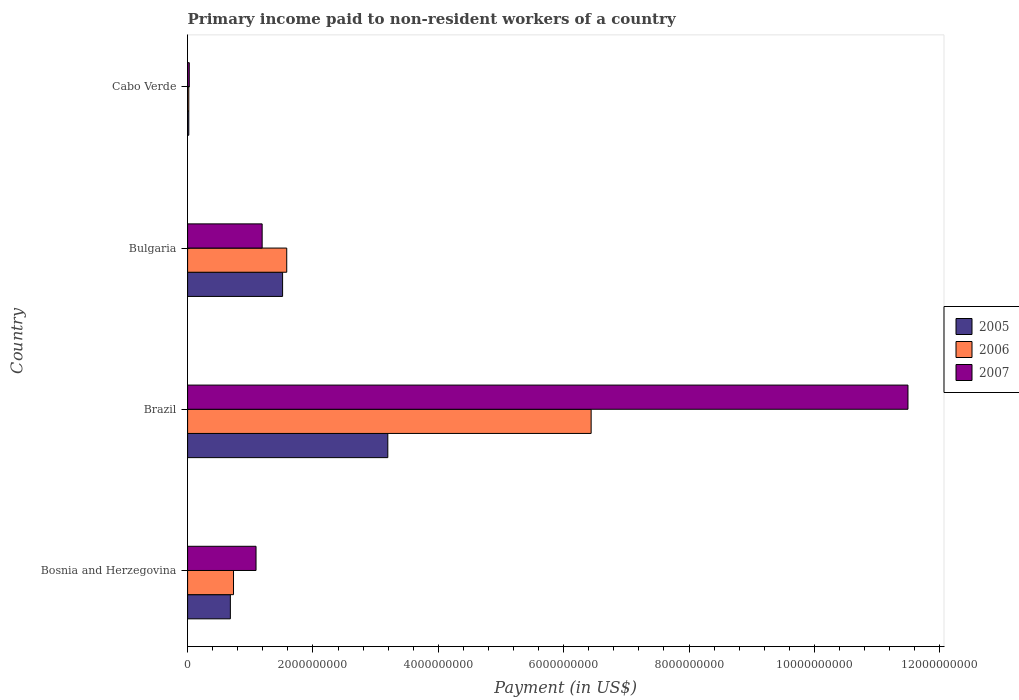How many different coloured bars are there?
Ensure brevity in your answer.  3. How many groups of bars are there?
Make the answer very short. 4. Are the number of bars per tick equal to the number of legend labels?
Give a very brief answer. Yes. Are the number of bars on each tick of the Y-axis equal?
Ensure brevity in your answer.  Yes. How many bars are there on the 1st tick from the top?
Your answer should be compact. 3. How many bars are there on the 4th tick from the bottom?
Provide a succinct answer. 3. What is the label of the 4th group of bars from the top?
Your answer should be very brief. Bosnia and Herzegovina. What is the amount paid to workers in 2006 in Bosnia and Herzegovina?
Ensure brevity in your answer.  7.33e+08. Across all countries, what is the maximum amount paid to workers in 2007?
Keep it short and to the point. 1.15e+1. Across all countries, what is the minimum amount paid to workers in 2006?
Keep it short and to the point. 1.91e+07. In which country was the amount paid to workers in 2006 minimum?
Keep it short and to the point. Cabo Verde. What is the total amount paid to workers in 2005 in the graph?
Keep it short and to the point. 5.41e+09. What is the difference between the amount paid to workers in 2007 in Bulgaria and that in Cabo Verde?
Provide a short and direct response. 1.16e+09. What is the difference between the amount paid to workers in 2007 in Cabo Verde and the amount paid to workers in 2006 in Brazil?
Offer a terse response. -6.41e+09. What is the average amount paid to workers in 2007 per country?
Provide a short and direct response. 3.45e+09. What is the difference between the amount paid to workers in 2005 and amount paid to workers in 2006 in Bosnia and Herzegovina?
Offer a terse response. -5.03e+07. In how many countries, is the amount paid to workers in 2006 greater than 2800000000 US$?
Your answer should be compact. 1. What is the ratio of the amount paid to workers in 2006 in Bosnia and Herzegovina to that in Cabo Verde?
Provide a short and direct response. 38.41. Is the difference between the amount paid to workers in 2005 in Brazil and Bulgaria greater than the difference between the amount paid to workers in 2006 in Brazil and Bulgaria?
Offer a very short reply. No. What is the difference between the highest and the second highest amount paid to workers in 2005?
Ensure brevity in your answer.  1.68e+09. What is the difference between the highest and the lowest amount paid to workers in 2007?
Offer a terse response. 1.15e+1. In how many countries, is the amount paid to workers in 2007 greater than the average amount paid to workers in 2007 taken over all countries?
Ensure brevity in your answer.  1. What does the 3rd bar from the bottom in Cabo Verde represents?
Give a very brief answer. 2007. Are the values on the major ticks of X-axis written in scientific E-notation?
Provide a succinct answer. No. How are the legend labels stacked?
Offer a very short reply. Vertical. What is the title of the graph?
Give a very brief answer. Primary income paid to non-resident workers of a country. What is the label or title of the X-axis?
Your answer should be very brief. Payment (in US$). What is the label or title of the Y-axis?
Offer a very short reply. Country. What is the Payment (in US$) of 2005 in Bosnia and Herzegovina?
Provide a succinct answer. 6.82e+08. What is the Payment (in US$) in 2006 in Bosnia and Herzegovina?
Give a very brief answer. 7.33e+08. What is the Payment (in US$) in 2007 in Bosnia and Herzegovina?
Ensure brevity in your answer.  1.09e+09. What is the Payment (in US$) in 2005 in Brazil?
Ensure brevity in your answer.  3.19e+09. What is the Payment (in US$) in 2006 in Brazil?
Your answer should be very brief. 6.44e+09. What is the Payment (in US$) in 2007 in Brazil?
Offer a very short reply. 1.15e+1. What is the Payment (in US$) of 2005 in Bulgaria?
Offer a terse response. 1.52e+09. What is the Payment (in US$) in 2006 in Bulgaria?
Ensure brevity in your answer.  1.58e+09. What is the Payment (in US$) in 2007 in Bulgaria?
Your answer should be very brief. 1.19e+09. What is the Payment (in US$) of 2005 in Cabo Verde?
Keep it short and to the point. 1.92e+07. What is the Payment (in US$) in 2006 in Cabo Verde?
Give a very brief answer. 1.91e+07. What is the Payment (in US$) of 2007 in Cabo Verde?
Give a very brief answer. 2.67e+07. Across all countries, what is the maximum Payment (in US$) of 2005?
Your answer should be compact. 3.19e+09. Across all countries, what is the maximum Payment (in US$) in 2006?
Give a very brief answer. 6.44e+09. Across all countries, what is the maximum Payment (in US$) of 2007?
Provide a short and direct response. 1.15e+1. Across all countries, what is the minimum Payment (in US$) of 2005?
Provide a short and direct response. 1.92e+07. Across all countries, what is the minimum Payment (in US$) in 2006?
Give a very brief answer. 1.91e+07. Across all countries, what is the minimum Payment (in US$) in 2007?
Give a very brief answer. 2.67e+07. What is the total Payment (in US$) of 2005 in the graph?
Your answer should be very brief. 5.41e+09. What is the total Payment (in US$) in 2006 in the graph?
Provide a short and direct response. 8.77e+09. What is the total Payment (in US$) in 2007 in the graph?
Give a very brief answer. 1.38e+1. What is the difference between the Payment (in US$) of 2005 in Bosnia and Herzegovina and that in Brazil?
Offer a terse response. -2.51e+09. What is the difference between the Payment (in US$) in 2006 in Bosnia and Herzegovina and that in Brazil?
Your answer should be very brief. -5.71e+09. What is the difference between the Payment (in US$) in 2007 in Bosnia and Herzegovina and that in Brazil?
Offer a terse response. -1.04e+1. What is the difference between the Payment (in US$) in 2005 in Bosnia and Herzegovina and that in Bulgaria?
Your answer should be compact. -8.33e+08. What is the difference between the Payment (in US$) in 2006 in Bosnia and Herzegovina and that in Bulgaria?
Keep it short and to the point. -8.49e+08. What is the difference between the Payment (in US$) of 2007 in Bosnia and Herzegovina and that in Bulgaria?
Provide a succinct answer. -9.75e+07. What is the difference between the Payment (in US$) in 2005 in Bosnia and Herzegovina and that in Cabo Verde?
Your response must be concise. 6.63e+08. What is the difference between the Payment (in US$) in 2006 in Bosnia and Herzegovina and that in Cabo Verde?
Your answer should be very brief. 7.14e+08. What is the difference between the Payment (in US$) in 2007 in Bosnia and Herzegovina and that in Cabo Verde?
Offer a terse response. 1.07e+09. What is the difference between the Payment (in US$) in 2005 in Brazil and that in Bulgaria?
Give a very brief answer. 1.68e+09. What is the difference between the Payment (in US$) in 2006 in Brazil and that in Bulgaria?
Provide a succinct answer. 4.86e+09. What is the difference between the Payment (in US$) of 2007 in Brazil and that in Bulgaria?
Keep it short and to the point. 1.03e+1. What is the difference between the Payment (in US$) of 2005 in Brazil and that in Cabo Verde?
Offer a very short reply. 3.18e+09. What is the difference between the Payment (in US$) in 2006 in Brazil and that in Cabo Verde?
Offer a terse response. 6.42e+09. What is the difference between the Payment (in US$) of 2007 in Brazil and that in Cabo Verde?
Provide a succinct answer. 1.15e+1. What is the difference between the Payment (in US$) in 2005 in Bulgaria and that in Cabo Verde?
Make the answer very short. 1.50e+09. What is the difference between the Payment (in US$) of 2006 in Bulgaria and that in Cabo Verde?
Provide a short and direct response. 1.56e+09. What is the difference between the Payment (in US$) of 2007 in Bulgaria and that in Cabo Verde?
Your answer should be compact. 1.16e+09. What is the difference between the Payment (in US$) of 2005 in Bosnia and Herzegovina and the Payment (in US$) of 2006 in Brazil?
Make the answer very short. -5.76e+09. What is the difference between the Payment (in US$) of 2005 in Bosnia and Herzegovina and the Payment (in US$) of 2007 in Brazil?
Keep it short and to the point. -1.08e+1. What is the difference between the Payment (in US$) of 2006 in Bosnia and Herzegovina and the Payment (in US$) of 2007 in Brazil?
Offer a very short reply. -1.08e+1. What is the difference between the Payment (in US$) in 2005 in Bosnia and Herzegovina and the Payment (in US$) in 2006 in Bulgaria?
Your answer should be compact. -8.99e+08. What is the difference between the Payment (in US$) of 2005 in Bosnia and Herzegovina and the Payment (in US$) of 2007 in Bulgaria?
Your response must be concise. -5.07e+08. What is the difference between the Payment (in US$) of 2006 in Bosnia and Herzegovina and the Payment (in US$) of 2007 in Bulgaria?
Ensure brevity in your answer.  -4.57e+08. What is the difference between the Payment (in US$) in 2005 in Bosnia and Herzegovina and the Payment (in US$) in 2006 in Cabo Verde?
Provide a short and direct response. 6.63e+08. What is the difference between the Payment (in US$) in 2005 in Bosnia and Herzegovina and the Payment (in US$) in 2007 in Cabo Verde?
Ensure brevity in your answer.  6.56e+08. What is the difference between the Payment (in US$) of 2006 in Bosnia and Herzegovina and the Payment (in US$) of 2007 in Cabo Verde?
Your answer should be very brief. 7.06e+08. What is the difference between the Payment (in US$) in 2005 in Brazil and the Payment (in US$) in 2006 in Bulgaria?
Provide a succinct answer. 1.61e+09. What is the difference between the Payment (in US$) of 2005 in Brazil and the Payment (in US$) of 2007 in Bulgaria?
Provide a short and direct response. 2.00e+09. What is the difference between the Payment (in US$) of 2006 in Brazil and the Payment (in US$) of 2007 in Bulgaria?
Provide a short and direct response. 5.25e+09. What is the difference between the Payment (in US$) of 2005 in Brazil and the Payment (in US$) of 2006 in Cabo Verde?
Offer a very short reply. 3.18e+09. What is the difference between the Payment (in US$) of 2005 in Brazil and the Payment (in US$) of 2007 in Cabo Verde?
Your answer should be very brief. 3.17e+09. What is the difference between the Payment (in US$) of 2006 in Brazil and the Payment (in US$) of 2007 in Cabo Verde?
Provide a short and direct response. 6.41e+09. What is the difference between the Payment (in US$) of 2005 in Bulgaria and the Payment (in US$) of 2006 in Cabo Verde?
Ensure brevity in your answer.  1.50e+09. What is the difference between the Payment (in US$) in 2005 in Bulgaria and the Payment (in US$) in 2007 in Cabo Verde?
Give a very brief answer. 1.49e+09. What is the difference between the Payment (in US$) in 2006 in Bulgaria and the Payment (in US$) in 2007 in Cabo Verde?
Give a very brief answer. 1.55e+09. What is the average Payment (in US$) in 2005 per country?
Keep it short and to the point. 1.35e+09. What is the average Payment (in US$) of 2006 per country?
Keep it short and to the point. 2.19e+09. What is the average Payment (in US$) of 2007 per country?
Offer a very short reply. 3.45e+09. What is the difference between the Payment (in US$) in 2005 and Payment (in US$) in 2006 in Bosnia and Herzegovina?
Offer a terse response. -5.03e+07. What is the difference between the Payment (in US$) of 2005 and Payment (in US$) of 2007 in Bosnia and Herzegovina?
Keep it short and to the point. -4.10e+08. What is the difference between the Payment (in US$) of 2006 and Payment (in US$) of 2007 in Bosnia and Herzegovina?
Provide a short and direct response. -3.59e+08. What is the difference between the Payment (in US$) of 2005 and Payment (in US$) of 2006 in Brazil?
Offer a terse response. -3.24e+09. What is the difference between the Payment (in US$) in 2005 and Payment (in US$) in 2007 in Brazil?
Your response must be concise. -8.30e+09. What is the difference between the Payment (in US$) in 2006 and Payment (in US$) in 2007 in Brazil?
Provide a short and direct response. -5.05e+09. What is the difference between the Payment (in US$) in 2005 and Payment (in US$) in 2006 in Bulgaria?
Your answer should be very brief. -6.60e+07. What is the difference between the Payment (in US$) of 2005 and Payment (in US$) of 2007 in Bulgaria?
Offer a terse response. 3.26e+08. What is the difference between the Payment (in US$) in 2006 and Payment (in US$) in 2007 in Bulgaria?
Your response must be concise. 3.92e+08. What is the difference between the Payment (in US$) of 2005 and Payment (in US$) of 2006 in Cabo Verde?
Offer a terse response. 1.54e+05. What is the difference between the Payment (in US$) of 2005 and Payment (in US$) of 2007 in Cabo Verde?
Your response must be concise. -7.50e+06. What is the difference between the Payment (in US$) of 2006 and Payment (in US$) of 2007 in Cabo Verde?
Keep it short and to the point. -7.66e+06. What is the ratio of the Payment (in US$) of 2005 in Bosnia and Herzegovina to that in Brazil?
Provide a succinct answer. 0.21. What is the ratio of the Payment (in US$) of 2006 in Bosnia and Herzegovina to that in Brazil?
Provide a succinct answer. 0.11. What is the ratio of the Payment (in US$) of 2007 in Bosnia and Herzegovina to that in Brazil?
Your answer should be compact. 0.1. What is the ratio of the Payment (in US$) in 2005 in Bosnia and Herzegovina to that in Bulgaria?
Ensure brevity in your answer.  0.45. What is the ratio of the Payment (in US$) of 2006 in Bosnia and Herzegovina to that in Bulgaria?
Your answer should be compact. 0.46. What is the ratio of the Payment (in US$) of 2007 in Bosnia and Herzegovina to that in Bulgaria?
Your answer should be very brief. 0.92. What is the ratio of the Payment (in US$) in 2005 in Bosnia and Herzegovina to that in Cabo Verde?
Make the answer very short. 35.49. What is the ratio of the Payment (in US$) in 2006 in Bosnia and Herzegovina to that in Cabo Verde?
Offer a very short reply. 38.41. What is the ratio of the Payment (in US$) of 2007 in Bosnia and Herzegovina to that in Cabo Verde?
Give a very brief answer. 40.85. What is the ratio of the Payment (in US$) in 2005 in Brazil to that in Bulgaria?
Your response must be concise. 2.11. What is the ratio of the Payment (in US$) in 2006 in Brazil to that in Bulgaria?
Your response must be concise. 4.07. What is the ratio of the Payment (in US$) of 2007 in Brazil to that in Bulgaria?
Provide a succinct answer. 9.66. What is the ratio of the Payment (in US$) in 2005 in Brazil to that in Cabo Verde?
Your answer should be compact. 166.14. What is the ratio of the Payment (in US$) of 2006 in Brazil to that in Cabo Verde?
Offer a terse response. 337.55. What is the ratio of the Payment (in US$) of 2007 in Brazil to that in Cabo Verde?
Offer a terse response. 429.95. What is the ratio of the Payment (in US$) of 2005 in Bulgaria to that in Cabo Verde?
Keep it short and to the point. 78.83. What is the ratio of the Payment (in US$) of 2006 in Bulgaria to that in Cabo Verde?
Keep it short and to the point. 82.93. What is the ratio of the Payment (in US$) in 2007 in Bulgaria to that in Cabo Verde?
Make the answer very short. 44.5. What is the difference between the highest and the second highest Payment (in US$) of 2005?
Ensure brevity in your answer.  1.68e+09. What is the difference between the highest and the second highest Payment (in US$) in 2006?
Ensure brevity in your answer.  4.86e+09. What is the difference between the highest and the second highest Payment (in US$) of 2007?
Your answer should be compact. 1.03e+1. What is the difference between the highest and the lowest Payment (in US$) in 2005?
Provide a succinct answer. 3.18e+09. What is the difference between the highest and the lowest Payment (in US$) of 2006?
Offer a very short reply. 6.42e+09. What is the difference between the highest and the lowest Payment (in US$) of 2007?
Give a very brief answer. 1.15e+1. 